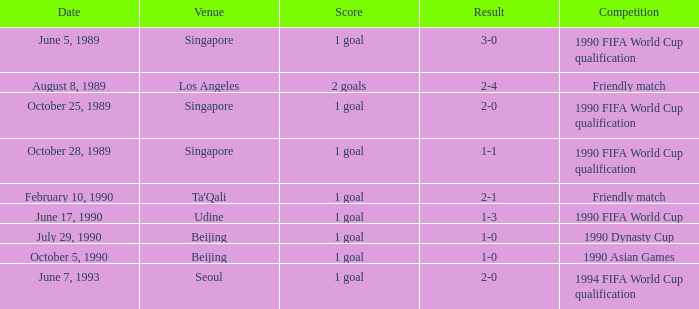What was the outcome of the game with a 3-0 result? 1 goal. 